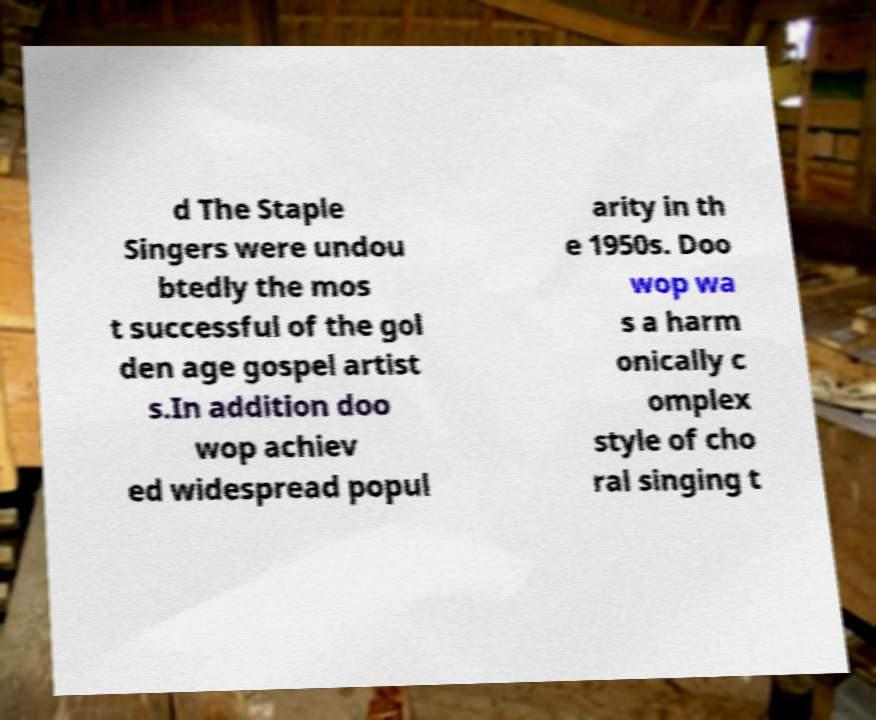For documentation purposes, I need the text within this image transcribed. Could you provide that? d The Staple Singers were undou btedly the mos t successful of the gol den age gospel artist s.In addition doo wop achiev ed widespread popul arity in th e 1950s. Doo wop wa s a harm onically c omplex style of cho ral singing t 